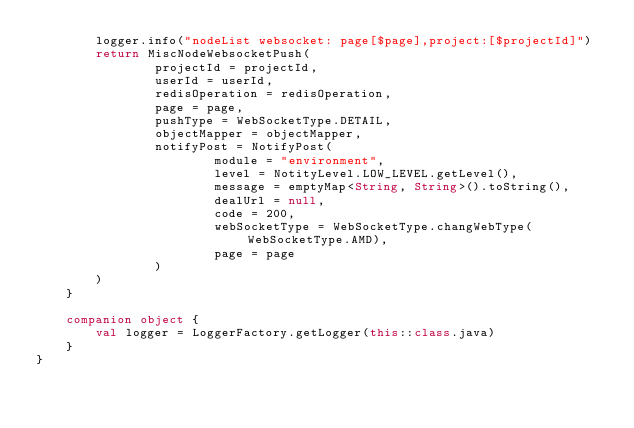Convert code to text. <code><loc_0><loc_0><loc_500><loc_500><_Kotlin_>        logger.info("nodeList websocket: page[$page],project:[$projectId]")
        return MiscNodeWebsocketPush(
                projectId = projectId,
                userId = userId,
                redisOperation = redisOperation,
                page = page,
                pushType = WebSocketType.DETAIL,
                objectMapper = objectMapper,
                notifyPost = NotifyPost(
                        module = "environment",
                        level = NotityLevel.LOW_LEVEL.getLevel(),
                        message = emptyMap<String, String>().toString(),
                        dealUrl = null,
                        code = 200,
                        webSocketType = WebSocketType.changWebType(WebSocketType.AMD),
                        page = page
                )
        )
    }

    companion object {
        val logger = LoggerFactory.getLogger(this::class.java)
    }
}</code> 